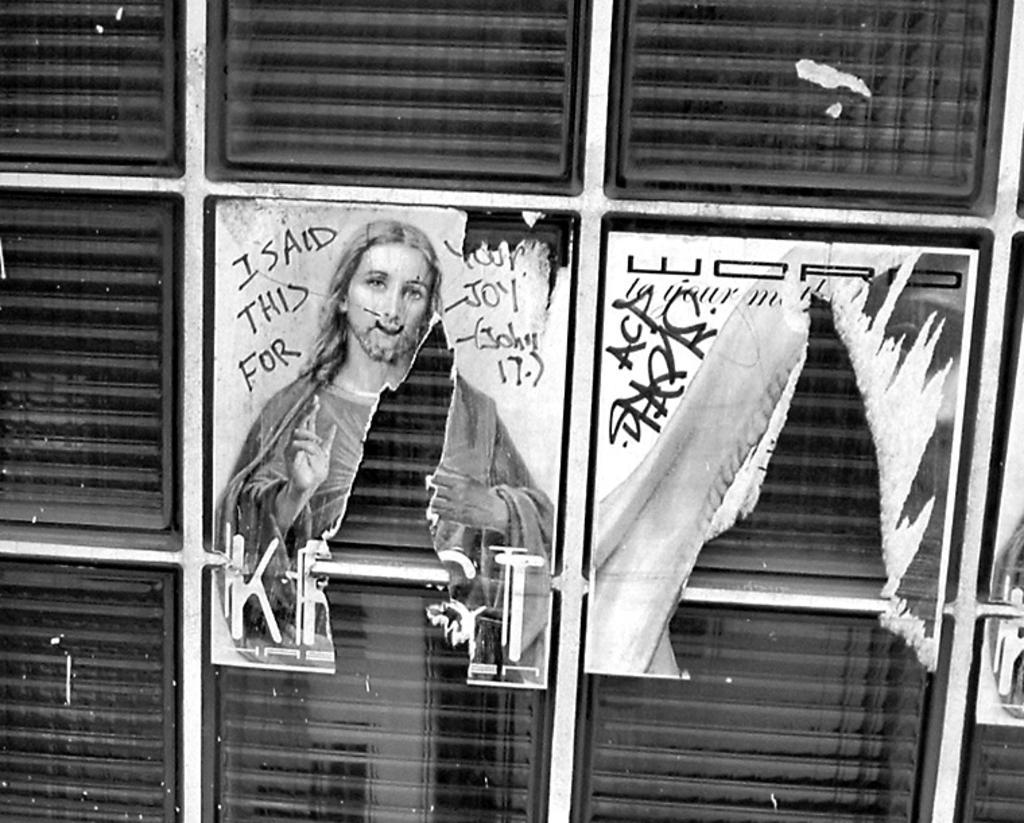In one or two sentences, can you explain what this image depicts? This is a zoomed in picture. In the center there is a black color object seems to be a cabinet. In the center we can see the picture of a person and a text on the cabinet. 